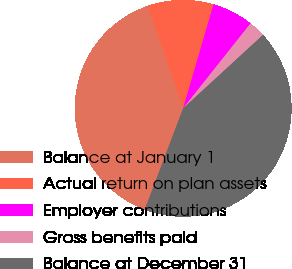Convert chart to OTSL. <chart><loc_0><loc_0><loc_500><loc_500><pie_chart><fcel>Balance at January 1<fcel>Actual return on plan assets<fcel>Employer contributions<fcel>Gross benefits paid<fcel>Balance at December 31<nl><fcel>38.95%<fcel>9.81%<fcel>6.15%<fcel>2.49%<fcel>42.61%<nl></chart> 